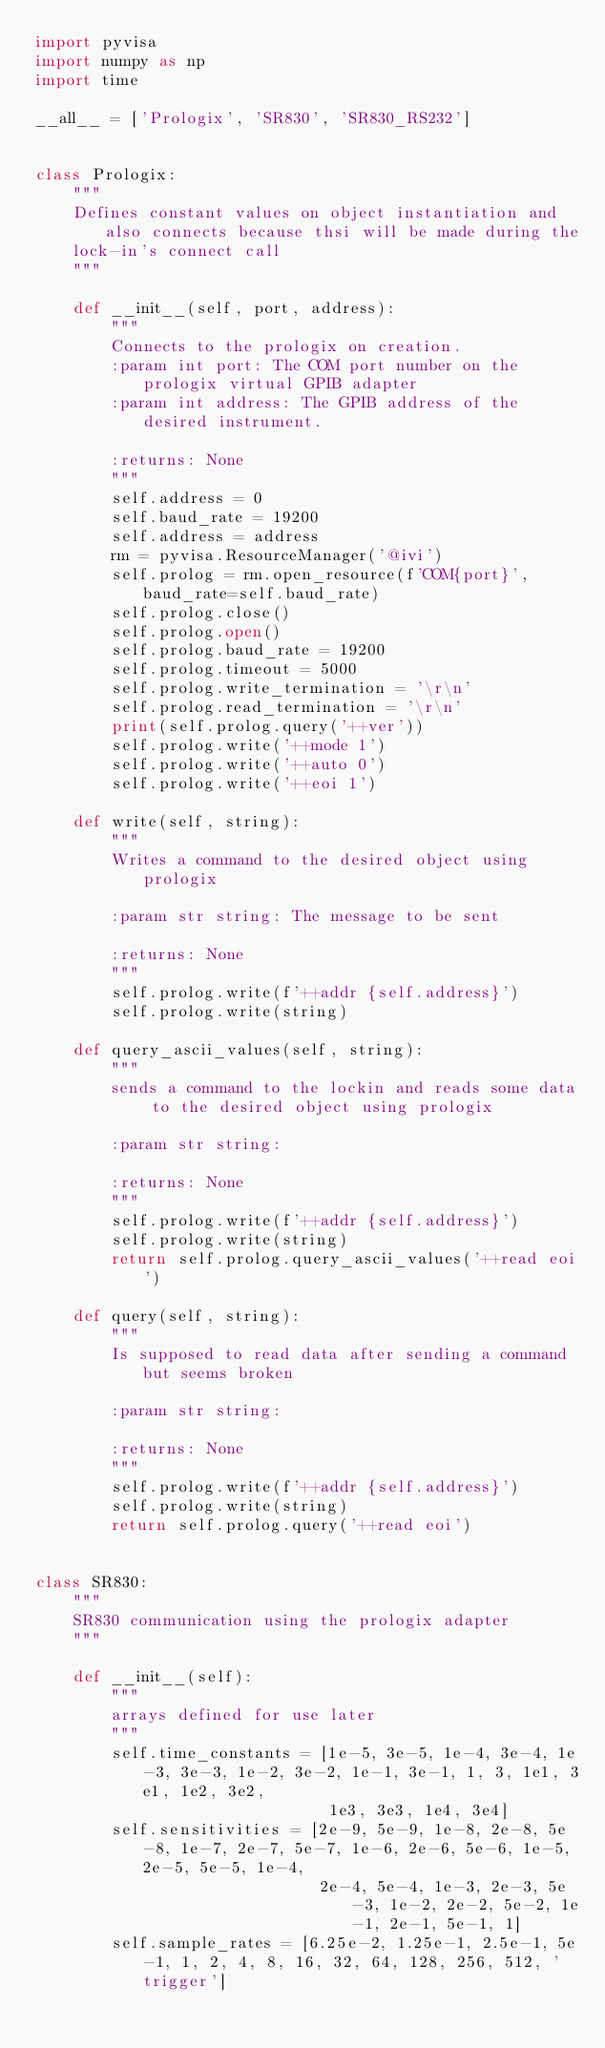Convert code to text. <code><loc_0><loc_0><loc_500><loc_500><_Python_>import pyvisa
import numpy as np
import time

__all__ = ['Prologix', 'SR830', 'SR830_RS232']


class Prologix:
    """
    Defines constant values on object instantiation and also connects because thsi will be made during the
    lock-in's connect call
    """

    def __init__(self, port, address):
        """
        Connects to the prologix on creation.
        :param int port: The COM port number on the prologix virtual GPIB adapter
        :param int address: The GPIB address of the desired instrument.

        :returns: None
        """
        self.address = 0
        self.baud_rate = 19200
        self.address = address
        rm = pyvisa.ResourceManager('@ivi')
        self.prolog = rm.open_resource(f'COM{port}', baud_rate=self.baud_rate)
        self.prolog.close()
        self.prolog.open()
        self.prolog.baud_rate = 19200
        self.prolog.timeout = 5000
        self.prolog.write_termination = '\r\n'
        self.prolog.read_termination = '\r\n'
        print(self.prolog.query('++ver'))
        self.prolog.write('++mode 1')
        self.prolog.write('++auto 0')
        self.prolog.write('++eoi 1')

    def write(self, string):
        """
        Writes a command to the desired object using prologix

        :param str string: The message to be sent

        :returns: None
        """
        self.prolog.write(f'++addr {self.address}')
        self.prolog.write(string)

    def query_ascii_values(self, string):
        """
        sends a command to the lockin and reads some data to the desired object using prologix

        :param str string:

        :returns: None
        """
        self.prolog.write(f'++addr {self.address}')
        self.prolog.write(string)
        return self.prolog.query_ascii_values('++read eoi')

    def query(self, string):
        """
        Is supposed to read data after sending a command but seems broken

        :param str string:

        :returns: None
        """
        self.prolog.write(f'++addr {self.address}')
        self.prolog.write(string)
        return self.prolog.query('++read eoi')


class SR830:
    """
    SR830 communication using the prologix adapter
    """

    def __init__(self):
        """
        arrays defined for use later
        """
        self.time_constants = [1e-5, 3e-5, 1e-4, 3e-4, 1e-3, 3e-3, 1e-2, 3e-2, 1e-1, 3e-1, 1, 3, 1e1, 3e1, 1e2, 3e2,
                               1e3, 3e3, 1e4, 3e4]
        self.sensitivities = [2e-9, 5e-9, 1e-8, 2e-8, 5e-8, 1e-7, 2e-7, 5e-7, 1e-6, 2e-6, 5e-6, 1e-5, 2e-5, 5e-5, 1e-4,
                              2e-4, 5e-4, 1e-3, 2e-3, 5e-3, 1e-2, 2e-2, 5e-2, 1e-1, 2e-1, 5e-1, 1]
        self.sample_rates = [6.25e-2, 1.25e-1, 2.5e-1, 5e-1, 1, 2, 4, 8, 16, 32, 64, 128, 256, 512, 'trigger']
</code> 